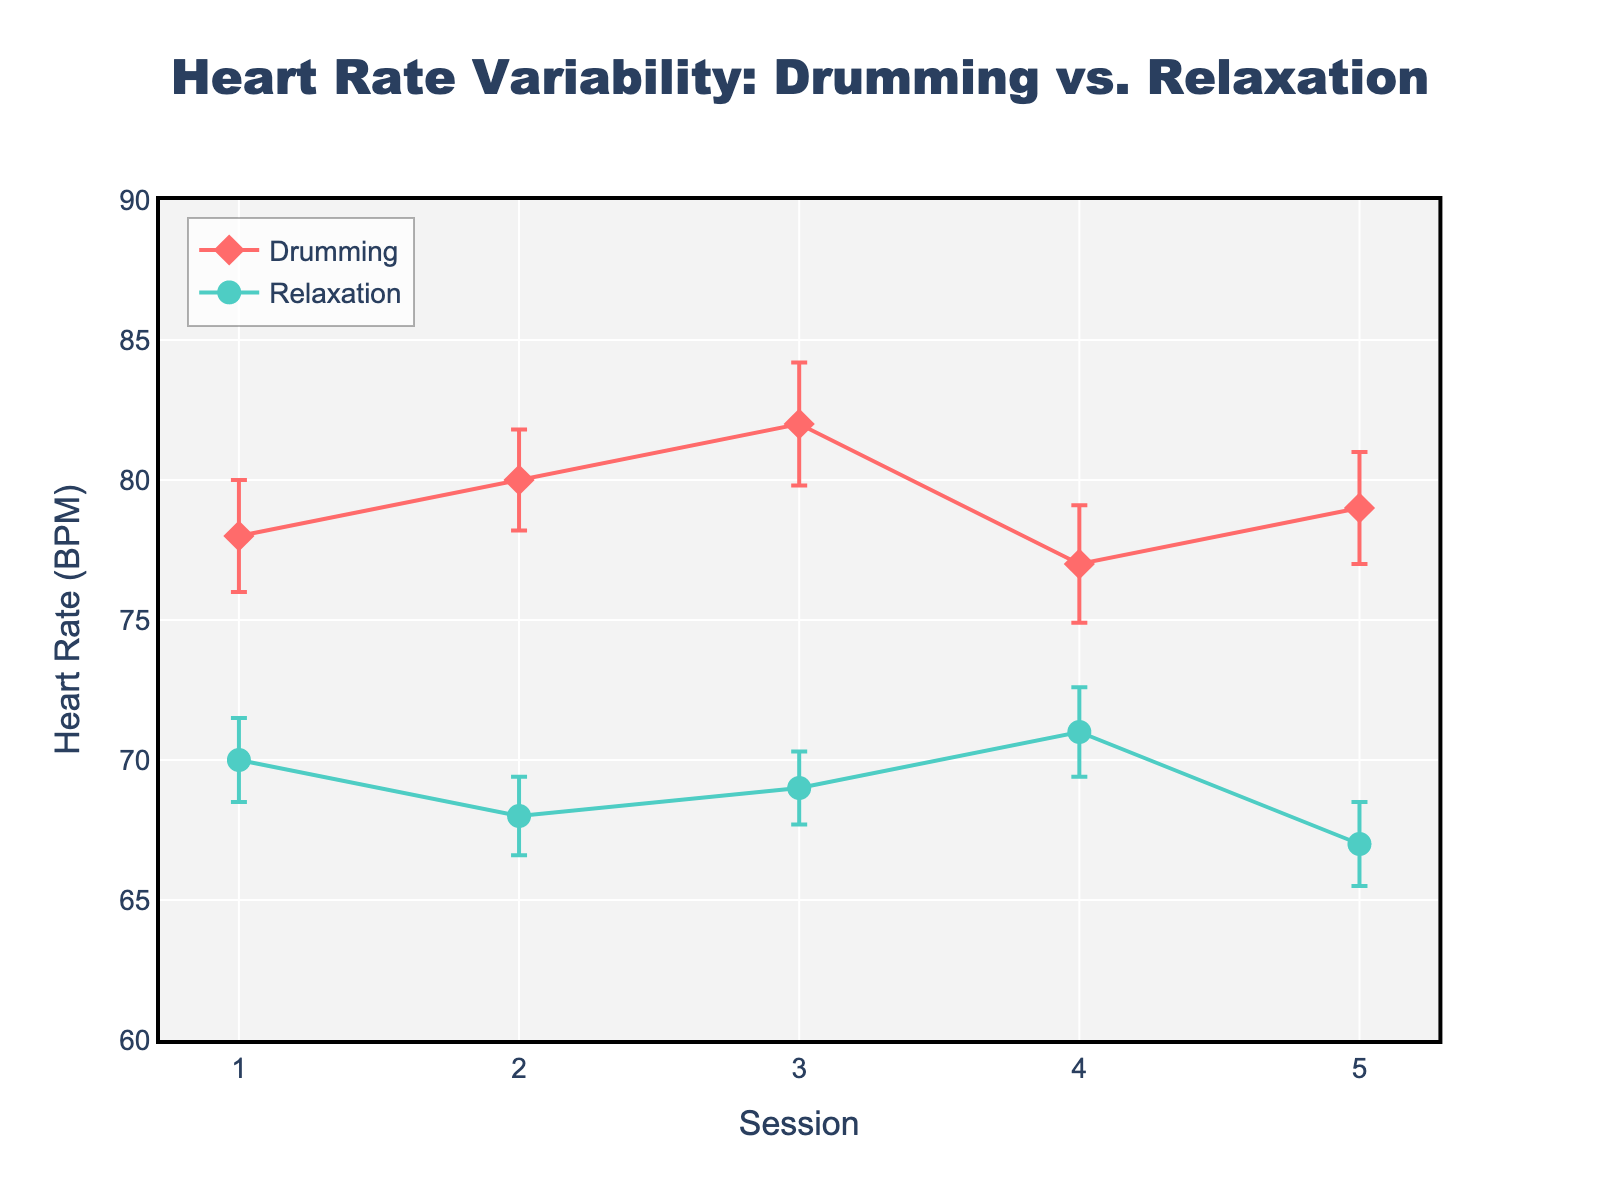what is the title of the figure? The title is usually displayed at the top of the figure and is in larger, bold text. It provides a concise summary of what the figure is about. In this case, it reads "Heart Rate Variability: Drumming vs. Relaxation".
Answer: Heart Rate Variability: Drumming vs. Relaxation On which session did Drumming result in the highest heart rate mean? The scatter plot markers show the mean heart rate on the y-axis for each session on the x-axis. The highest point for Drumming markers indicates the session with the highest mean heart rate.
Answer: Session 3 How much higher is the mean heart rate for Drumming than Relaxation in Session 2? Locate the data points for Session 2 for both Drumming and Relaxation. Subtract the Relaxation heart rate mean from the Drumming heart rate mean. The values are 80 BPM for Drumming and 68 BPM for Relaxation.
Answer: 12 BPM What is the range of heart rates observed across all sessions? The range can be calculated by finding the difference between the highest and lowest heart rate means across all sessions. The highest is 82 BPM (Session 3, Drumming), and the lowest is 67 BPM (Session 5, Relaxation).
Answer: 15 BPM In which session is the standard error the smallest for Relaxation? The standard error is shown as error bars. The smallest error bar for Relaxation indicates the session with the smallest standard error. The error bar that appears shortest is from Session 3.
Answer: Session 3 How do the heart rate means compare between Drumming and Relaxation in Session 4? Check the scatter plot where Session 4 data points for Drumming and Relaxation are plotted. Drumming shows a mean heart rate of 77 BPM and Relaxation shows a mean heart rate of 71 BPM. Compare these values.
Answer: Drumming: 77 BPM, Relaxation: 71 BPM Which condition generally shows higher heart rate means across the sessions? Observe the trends of the scatter plots for Drumming and Relaxation across all sessions. Almost all drumming data points are above the relaxation points, indicating higher heart rate means.
Answer: Drumming What is the difference in heart rate means between Drumming and Relaxation in Session 5? Find and subtract the Relaxation heart rate mean from the Drumming heart rate mean for Session 5. The values are 79 BPM for Drumming and 67 BPM for Relaxation.
Answer: 12 BPM Does the heart rate in Drumming remain relatively stable or vary significantly across sessions? Evaluate the variations in the heart rate means for Drumming across sessions by observing the heights of the scatter plot markers for Drumming. The heart rates range from 77 BPM to 82 BPM, suggesting moderate variability.
Answer: Vary significantly 